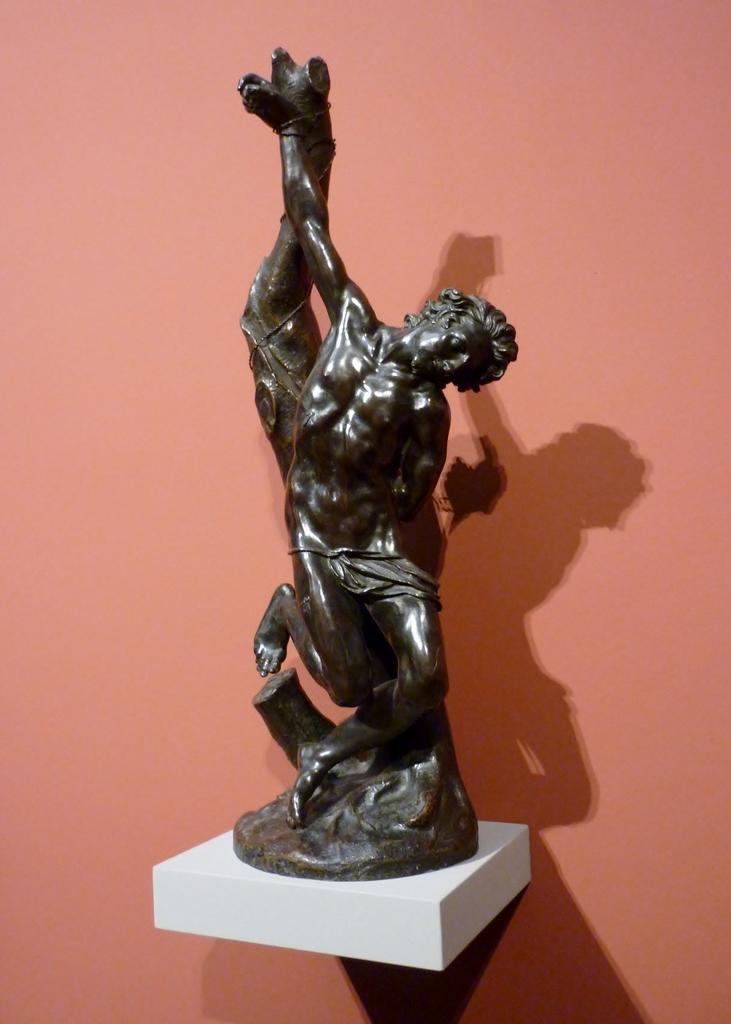What is the main subject in the center of the image? There is a statue at the center of the image. What can be seen behind the statue? There is a wall at the back side of the image. What type of animal is sitting on the wrist of the statue in the image? There is no animal present on the wrist of the statue in the image. 